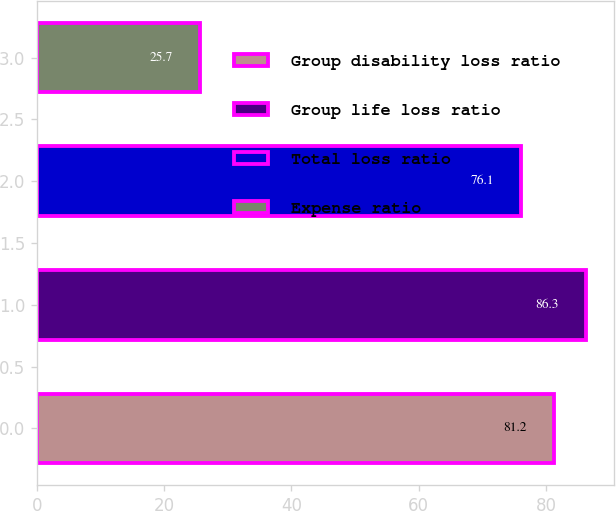<chart> <loc_0><loc_0><loc_500><loc_500><bar_chart><fcel>Group disability loss ratio<fcel>Group life loss ratio<fcel>Total loss ratio<fcel>Expense ratio<nl><fcel>81.2<fcel>86.3<fcel>76.1<fcel>25.7<nl></chart> 